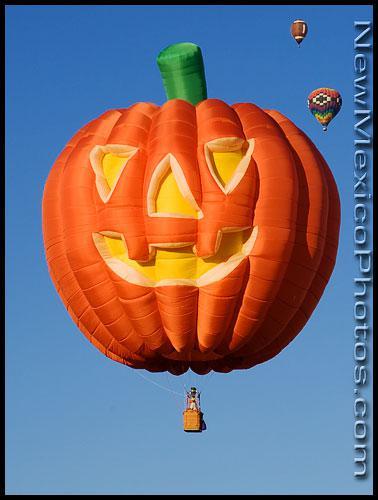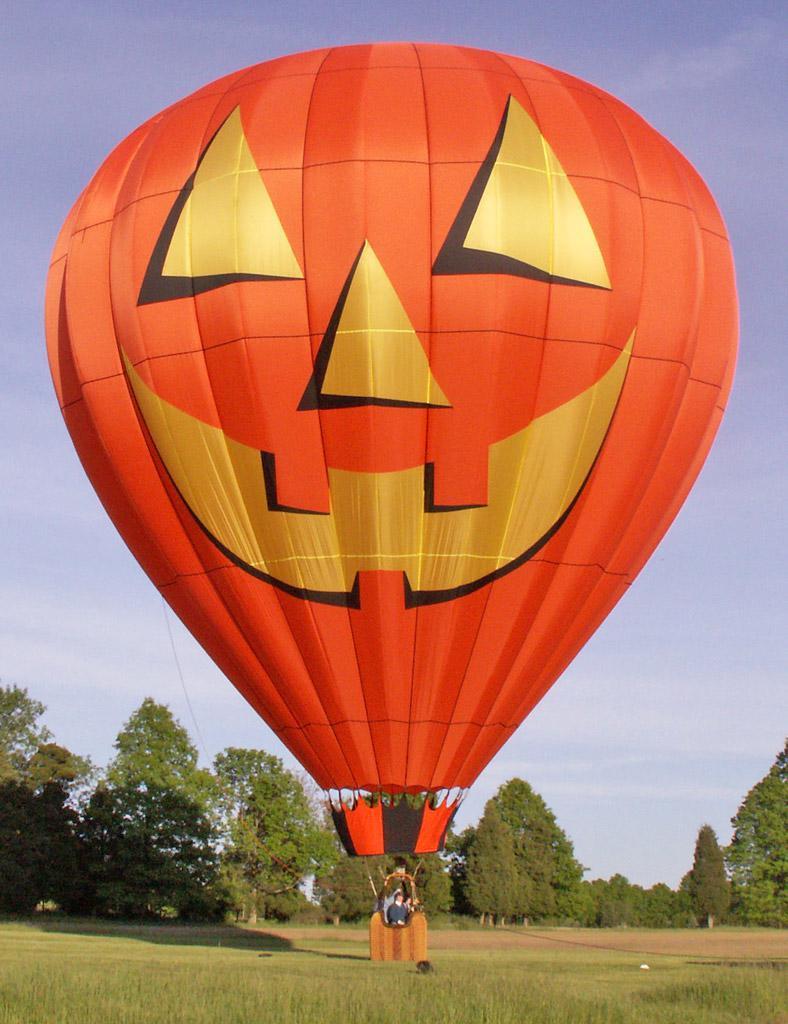The first image is the image on the left, the second image is the image on the right. Analyze the images presented: Is the assertion "Left image shows a balloon with multi-colored squarish shapes." valid? Answer yes or no. No. The first image is the image on the left, the second image is the image on the right. Evaluate the accuracy of this statement regarding the images: "One hot air balloon is sitting on a grassy area and one is floating in the air.". Is it true? Answer yes or no. Yes. 